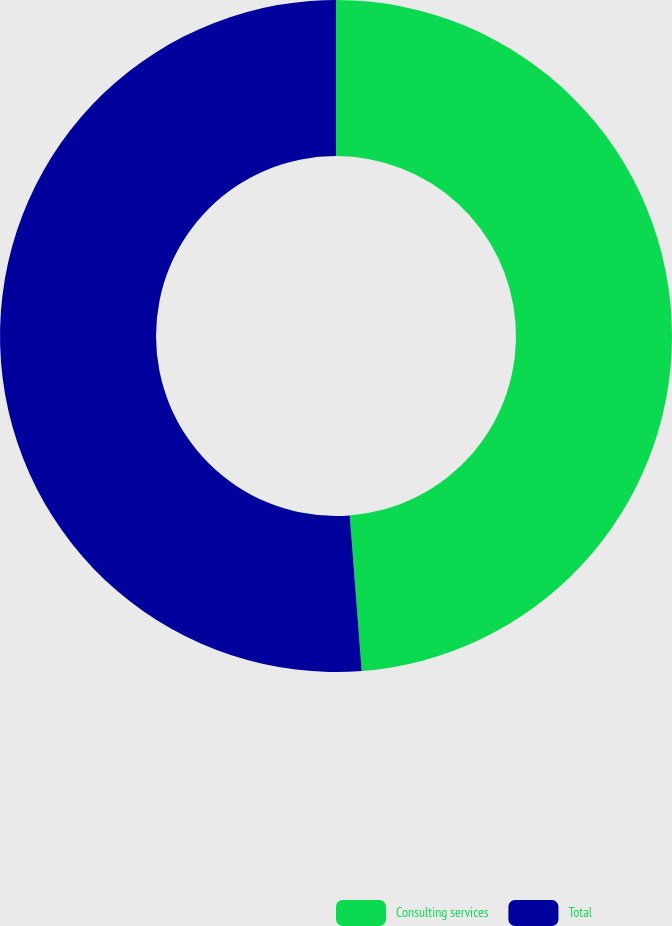Convert chart. <chart><loc_0><loc_0><loc_500><loc_500><pie_chart><fcel>Consulting services<fcel>Total<nl><fcel>48.78%<fcel>51.22%<nl></chart> 